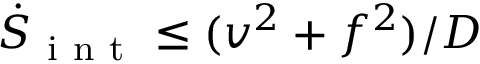Convert formula to latex. <formula><loc_0><loc_0><loc_500><loc_500>\dot { S } _ { i n t } \leq ( v ^ { 2 } + f ^ { 2 } ) / D</formula> 